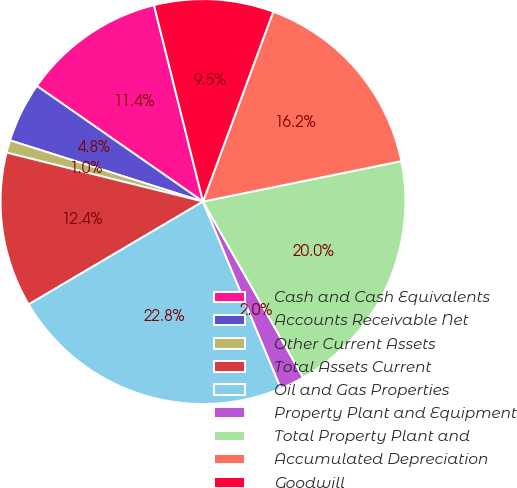<chart> <loc_0><loc_0><loc_500><loc_500><pie_chart><fcel>Cash and Cash Equivalents<fcel>Accounts Receivable Net<fcel>Other Current Assets<fcel>Total Assets Current<fcel>Oil and Gas Properties<fcel>Property Plant and Equipment<fcel>Total Property Plant and<fcel>Accumulated Depreciation<fcel>Goodwill<nl><fcel>11.43%<fcel>4.79%<fcel>1.0%<fcel>12.37%<fcel>22.8%<fcel>1.95%<fcel>19.96%<fcel>16.16%<fcel>9.53%<nl></chart> 